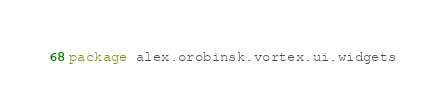<code> <loc_0><loc_0><loc_500><loc_500><_Kotlin_>package alex.orobinsk.vortex.ui.widgets
</code> 